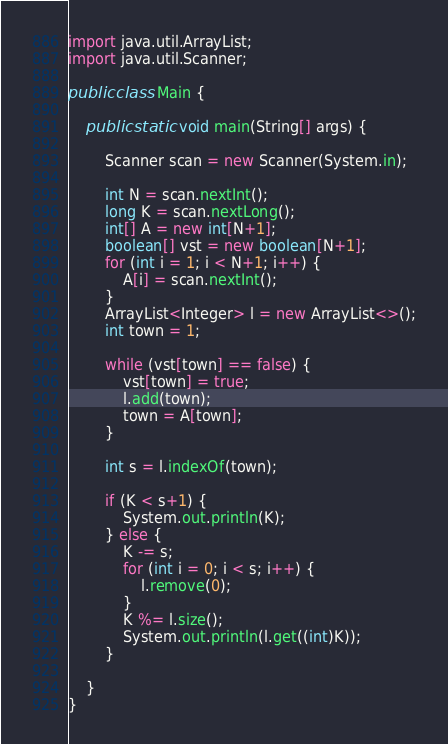Convert code to text. <code><loc_0><loc_0><loc_500><loc_500><_Java_>import java.util.ArrayList;
import java.util.Scanner;

public class Main {

	public static void main(String[] args) {

		Scanner scan = new Scanner(System.in);

		int N = scan.nextInt();
		long K = scan.nextLong();
		int[] A = new int[N+1];
		boolean[] vst = new boolean[N+1];
		for (int i = 1; i < N+1; i++) {
			A[i] = scan.nextInt();
		}
		ArrayList<Integer> l = new ArrayList<>();
		int town = 1;

		while (vst[town] == false) {
			vst[town] = true;
			l.add(town);
			town = A[town];
		}

		int s = l.indexOf(town);

		if (K < s+1) {
			System.out.println(K);
		} else {
			K -= s;
			for (int i = 0; i < s; i++) {
				l.remove(0);
			}
			K %= l.size();
			System.out.println(l.get((int)K));
		}

	}
}
</code> 